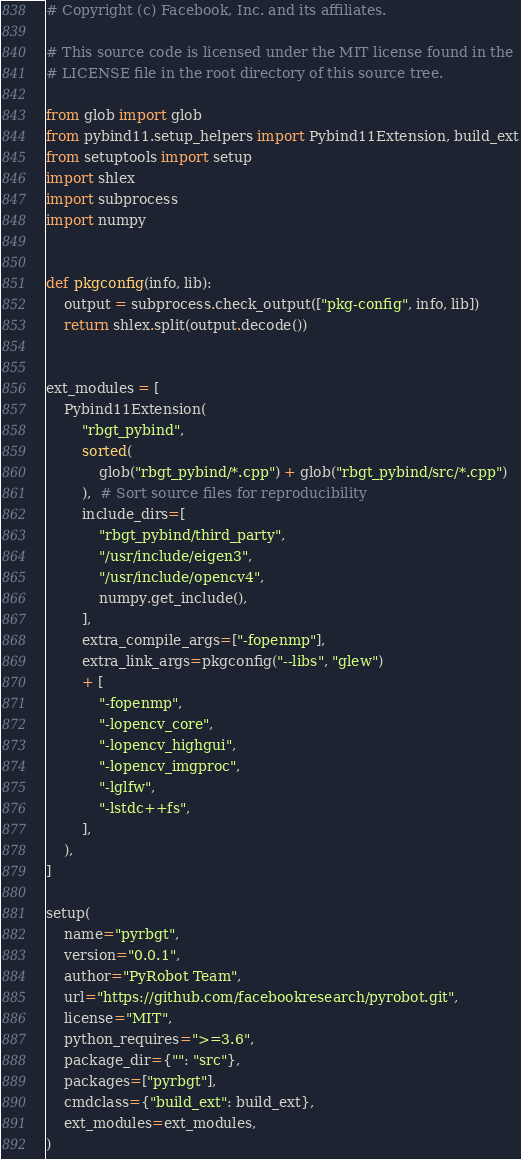Convert code to text. <code><loc_0><loc_0><loc_500><loc_500><_Python_># Copyright (c) Facebook, Inc. and its affiliates.

# This source code is licensed under the MIT license found in the
# LICENSE file in the root directory of this source tree.

from glob import glob
from pybind11.setup_helpers import Pybind11Extension, build_ext
from setuptools import setup
import shlex
import subprocess
import numpy


def pkgconfig(info, lib):
    output = subprocess.check_output(["pkg-config", info, lib])
    return shlex.split(output.decode())


ext_modules = [
    Pybind11Extension(
        "rbgt_pybind",
        sorted(
            glob("rbgt_pybind/*.cpp") + glob("rbgt_pybind/src/*.cpp")
        ),  # Sort source files for reproducibility
        include_dirs=[
            "rbgt_pybind/third_party",
            "/usr/include/eigen3",
            "/usr/include/opencv4",
            numpy.get_include(),
        ],
        extra_compile_args=["-fopenmp"],
        extra_link_args=pkgconfig("--libs", "glew")
        + [
            "-fopenmp",
            "-lopencv_core",
            "-lopencv_highgui",
            "-lopencv_imgproc",
            "-lglfw",
            "-lstdc++fs",
        ],
    ),
]

setup(
    name="pyrbgt",
    version="0.0.1",
    author="PyRobot Team",
    url="https://github.com/facebookresearch/pyrobot.git",
    license="MIT",
    python_requires=">=3.6",
    package_dir={"": "src"},
    packages=["pyrbgt"],
    cmdclass={"build_ext": build_ext},
    ext_modules=ext_modules,
)
</code> 